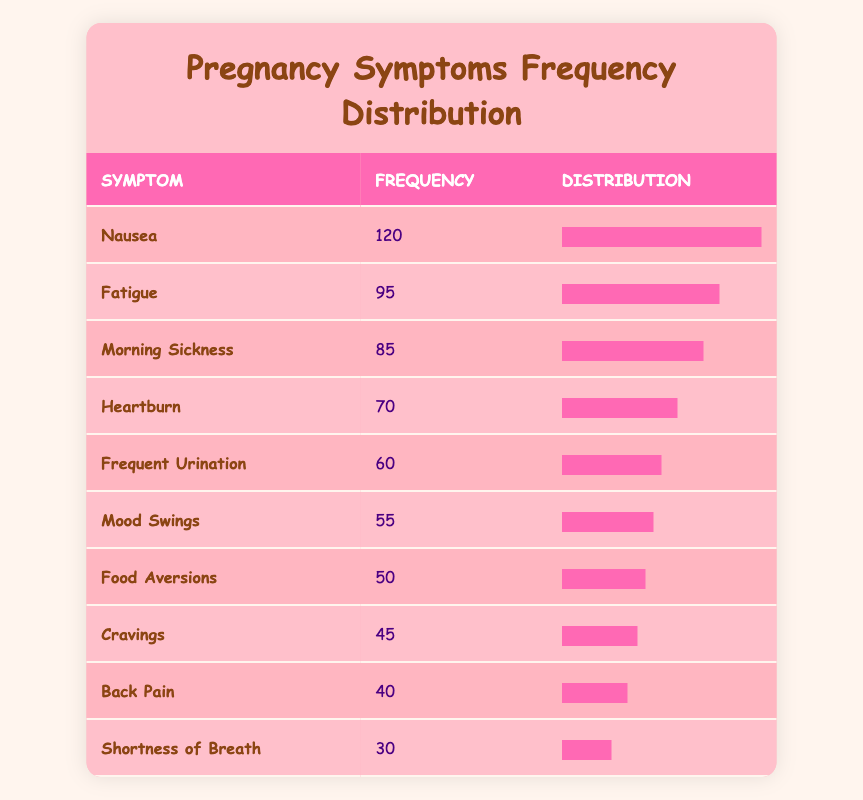What pregnancy symptom is reported the most frequently? The table shows that "Nausea" has the highest frequency at 120 occurrences.
Answer: Nausea What is the frequency of the symptom "Fatigue"? Looking at the table, "Fatigue" has a frequency of 95 reported occurrences.
Answer: 95 Is "Heartburn" more frequently reported than "Mood Swings"? The frequency for "Heartburn" is 70 while "Mood Swings" is 55. Since 70 is greater than 55, "Heartburn" is reported more frequently.
Answer: Yes What is the total frequency of the top three symptoms: "Nausea," "Fatigue," and "Morning Sickness"? The frequencies for those symptoms are 120 (Nausea), 95 (Fatigue), and 85 (Morning Sickness). Summing them gives 120 + 95 + 85 = 300.
Answer: 300 How many symptoms have a frequency of less than 60? The symptoms with frequencies less than 60 are "Frequent Urination" (60), "Mood Swings" (55), "Food Aversions" (50), "Cravings" (45), "Back Pain" (40), and "Shortness of Breath" (30). There are 5 symptoms that meet this criterion.
Answer: 5 Which symptom has the lowest frequency, and what is that frequency? The table indicates that "Shortness of Breath" has the lowest frequency at 30.
Answer: Shortness of Breath - 30 What is the average frequency of all the listed symptoms? The total frequency of all symptoms can be calculated: 120 + 95 + 85 + 70 + 60 + 55 + 50 + 45 + 40 + 30 = 750. There are 10 symptoms, so the average is 750 / 10 = 75.
Answer: 75 Does "Food Aversions" have a higher frequency than "Back Pain"? "Food Aversions" has a frequency of 50, while "Back Pain" has a frequency of 40. Since 50 is greater than 40, "Food Aversions" does have a higher frequency.
Answer: Yes What are the top two symptoms with the highest frequency, and what are their values? The top two symptoms according to the table are "Nausea" with 120, and "Fatigue" with 95.
Answer: Nausea - 120, Fatigue - 95 